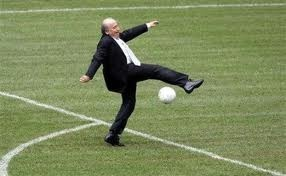Describe the objects in this image and their specific colors. I can see people in olive, black, white, gray, and darkgray tones, sports ball in olive, ivory, darkgray, and gray tones, and tie in olive, white, darkgray, beige, and gray tones in this image. 